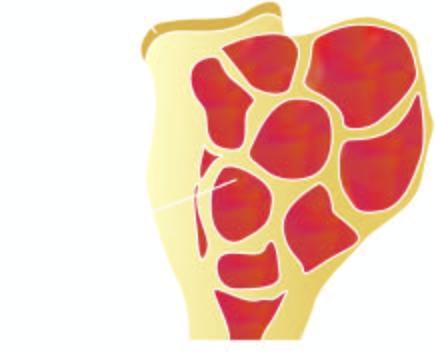what is the end of the long bone expanded in?
Answer the question using a single word or phrase. Region of epiphysis 